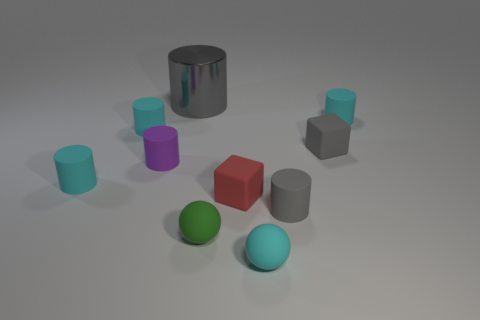Is the color of the rubber cube that is right of the small red cube the same as the large shiny thing?
Your answer should be compact. Yes. There is a tiny green object that is to the left of the small cyan matte sphere that is to the right of the small purple matte cylinder; what is its shape?
Your answer should be very brief. Sphere. What number of things are either small matte things that are left of the big gray object or tiny gray things to the right of the tiny red rubber object?
Your response must be concise. 5. The small green object that is the same material as the red cube is what shape?
Offer a very short reply. Sphere. What material is the gray thing that is the same shape as the tiny red thing?
Offer a very short reply. Rubber. What number of other things are the same size as the red rubber object?
Your answer should be compact. 8. What material is the large gray cylinder?
Ensure brevity in your answer.  Metal. Is the number of small green matte balls that are right of the big metallic thing greater than the number of big blue spheres?
Give a very brief answer. Yes. Are any tiny cyan objects visible?
Your answer should be compact. Yes. What number of other objects are the same shape as the small red matte object?
Give a very brief answer. 1. 